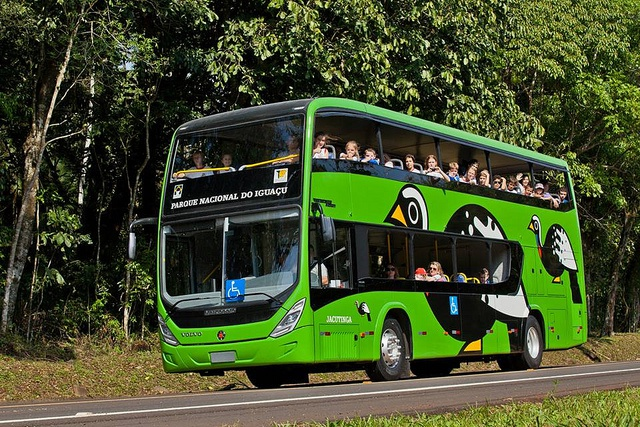Describe the objects in this image and their specific colors. I can see bus in black, green, gray, and lime tones, bird in black, lightgray, gray, and darkgray tones, people in black, gray, darkgray, and maroon tones, bird in black, lightgray, darkgreen, and darkgray tones, and people in black, lightgray, tan, and maroon tones in this image. 